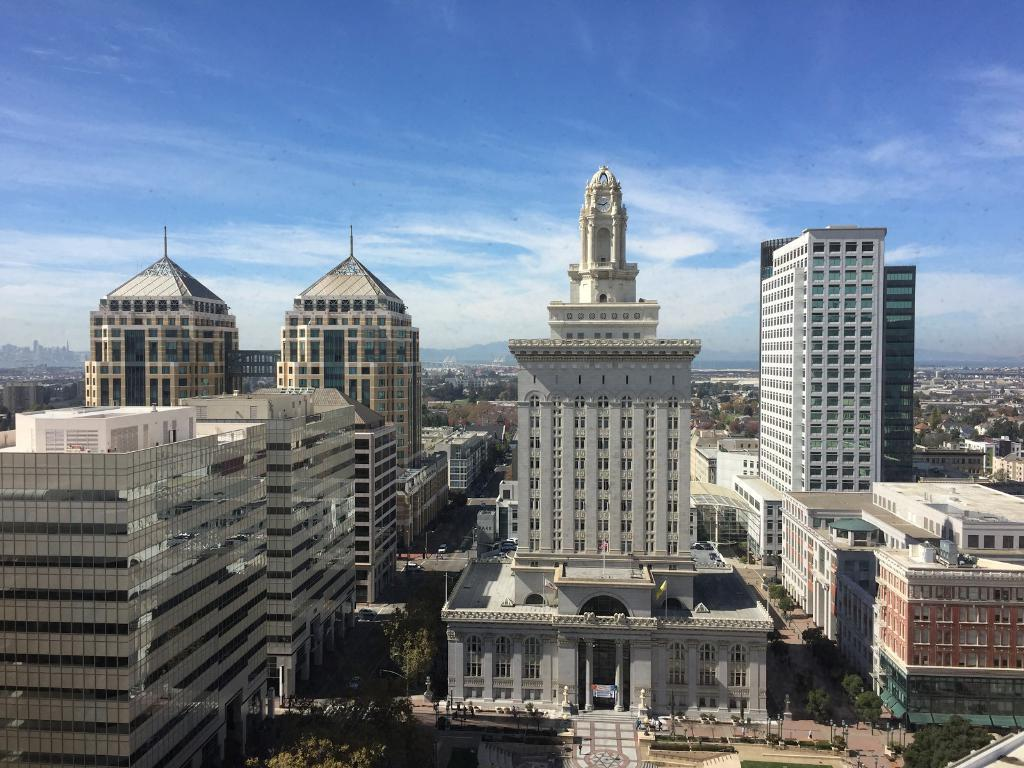What type of structures can be seen in the image? There are buildings in the image. What other natural elements are present in the image? There are trees in the image. What is the man-made path in the image? There is a road in the image. What are the moving objects in the image? There are vehicles in the image. What is visible above the buildings and trees? The sky is visible in the image. What can be observed in the sky? Clouds are present in the sky. Where is the lake located in the image? There is no lake present in the image. What type of flame can be seen coming from the vehicles in the image? There are no flames visible in the image; the vehicles are not on fire. 